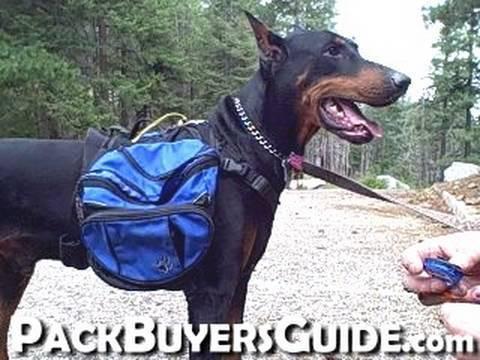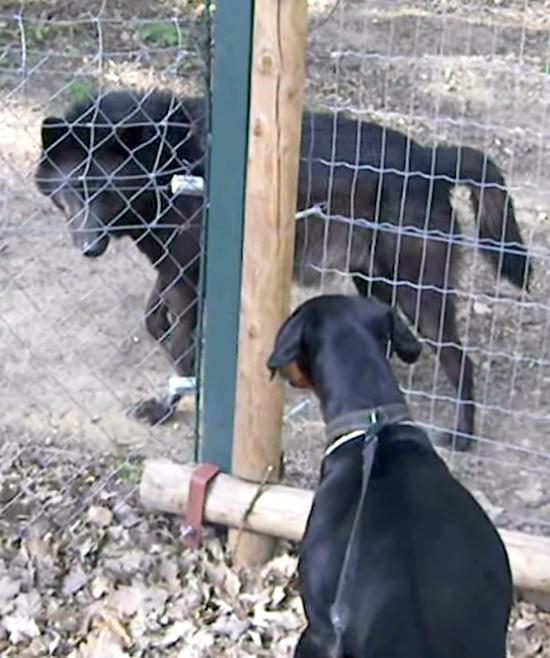The first image is the image on the left, the second image is the image on the right. Considering the images on both sides, is "A man with a backpack is standing with a dog in the image on the left." valid? Answer yes or no. No. 